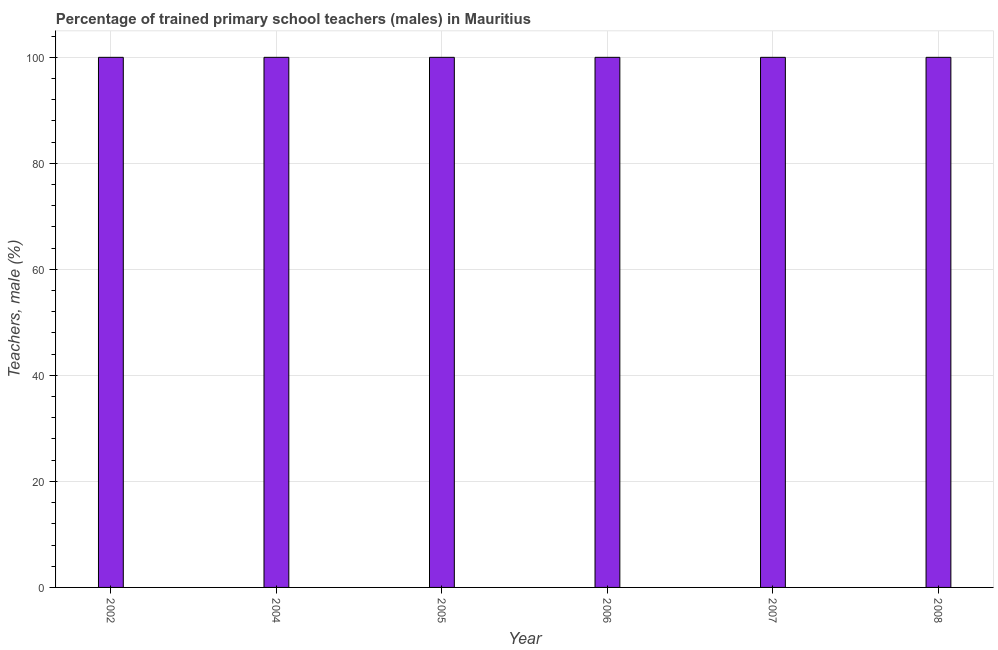What is the title of the graph?
Your answer should be very brief. Percentage of trained primary school teachers (males) in Mauritius. What is the label or title of the X-axis?
Your answer should be very brief. Year. What is the label or title of the Y-axis?
Give a very brief answer. Teachers, male (%). What is the percentage of trained male teachers in 2005?
Make the answer very short. 100. Across all years, what is the maximum percentage of trained male teachers?
Keep it short and to the point. 100. In which year was the percentage of trained male teachers minimum?
Your response must be concise. 2002. What is the sum of the percentage of trained male teachers?
Keep it short and to the point. 600. What is the difference between the percentage of trained male teachers in 2005 and 2006?
Your answer should be compact. 0. What is the average percentage of trained male teachers per year?
Offer a terse response. 100. In how many years, is the percentage of trained male teachers greater than 56 %?
Give a very brief answer. 6. What is the ratio of the percentage of trained male teachers in 2004 to that in 2007?
Your answer should be very brief. 1. Is the percentage of trained male teachers in 2006 less than that in 2008?
Your answer should be very brief. No. Is the difference between the percentage of trained male teachers in 2004 and 2008 greater than the difference between any two years?
Give a very brief answer. Yes. How many bars are there?
Offer a terse response. 6. How many years are there in the graph?
Offer a terse response. 6. Are the values on the major ticks of Y-axis written in scientific E-notation?
Ensure brevity in your answer.  No. What is the Teachers, male (%) of 2004?
Ensure brevity in your answer.  100. What is the Teachers, male (%) of 2005?
Provide a succinct answer. 100. What is the Teachers, male (%) of 2006?
Your answer should be compact. 100. What is the Teachers, male (%) in 2007?
Offer a terse response. 100. What is the difference between the Teachers, male (%) in 2002 and 2004?
Your answer should be compact. 0. What is the difference between the Teachers, male (%) in 2002 and 2005?
Provide a succinct answer. 0. What is the difference between the Teachers, male (%) in 2002 and 2006?
Ensure brevity in your answer.  0. What is the difference between the Teachers, male (%) in 2004 and 2005?
Provide a succinct answer. 0. What is the difference between the Teachers, male (%) in 2004 and 2007?
Give a very brief answer. 0. What is the difference between the Teachers, male (%) in 2004 and 2008?
Provide a short and direct response. 0. What is the difference between the Teachers, male (%) in 2005 and 2008?
Keep it short and to the point. 0. What is the difference between the Teachers, male (%) in 2007 and 2008?
Offer a terse response. 0. What is the ratio of the Teachers, male (%) in 2002 to that in 2004?
Ensure brevity in your answer.  1. What is the ratio of the Teachers, male (%) in 2002 to that in 2005?
Keep it short and to the point. 1. What is the ratio of the Teachers, male (%) in 2002 to that in 2008?
Offer a very short reply. 1. What is the ratio of the Teachers, male (%) in 2004 to that in 2005?
Keep it short and to the point. 1. What is the ratio of the Teachers, male (%) in 2004 to that in 2006?
Offer a terse response. 1. What is the ratio of the Teachers, male (%) in 2006 to that in 2008?
Provide a succinct answer. 1. 